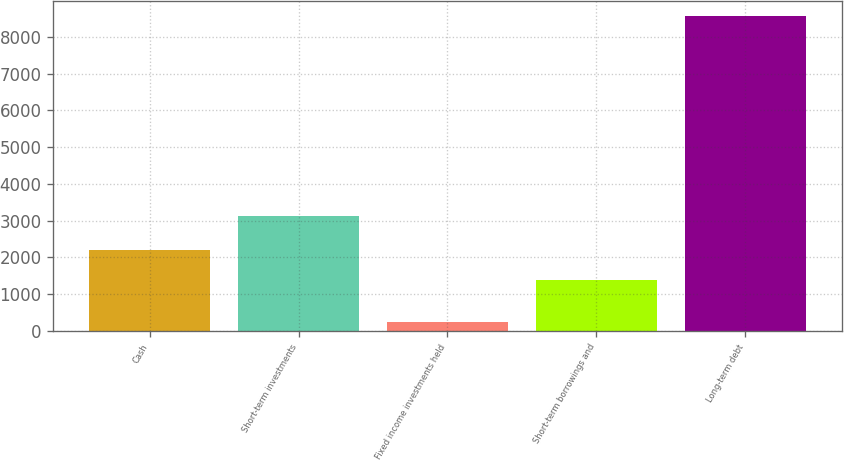Convert chart. <chart><loc_0><loc_0><loc_500><loc_500><bar_chart><fcel>Cash<fcel>Short-term investments<fcel>Fixed income investments held<fcel>Short-term borrowings and<fcel>Long-term debt<nl><fcel>2207<fcel>3122<fcel>256<fcel>1377<fcel>8556<nl></chart> 